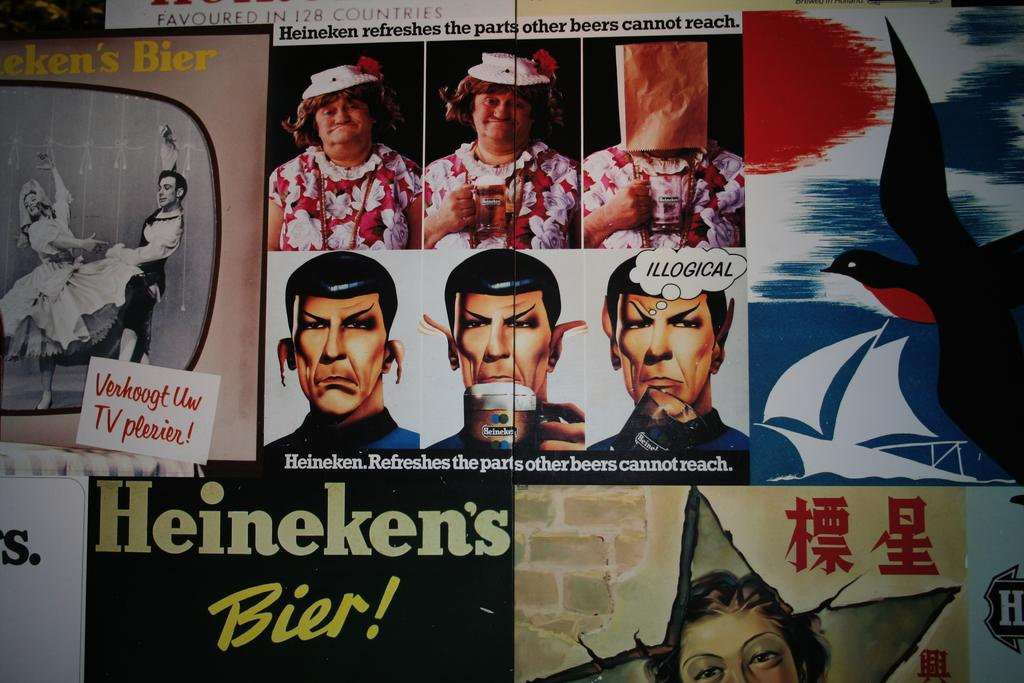What type of objects are featured on the posters in the image? The posters contain pictures of persons. Are there any other subjects depicted on the posters? Yes, there is a depiction of a bird in the image. What else can be seen on the posters besides the images? There is text written on the posters. Can you describe the other pictures in the image? There are pictures of more people in the image. What type of gold object is featured in the image? There is no gold object present in the image. Can you tell me how many eggnogs are depicted in the image? There are no eggnogs depicted in the image. 